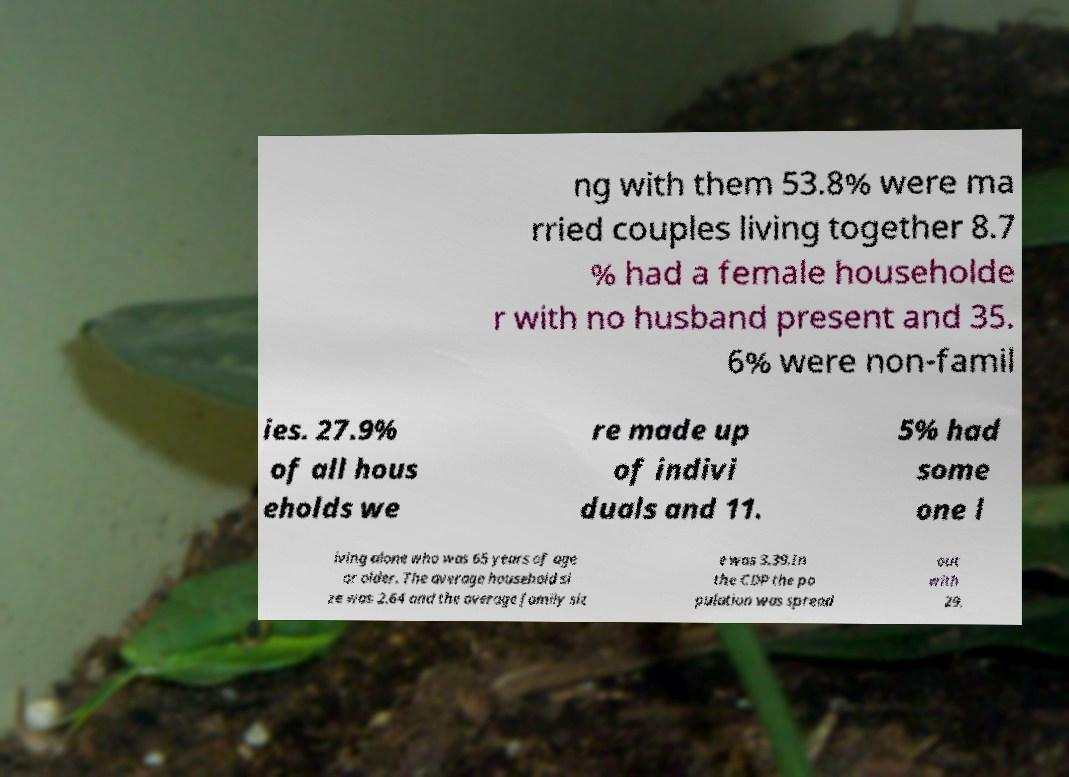Please identify and transcribe the text found in this image. ng with them 53.8% were ma rried couples living together 8.7 % had a female householde r with no husband present and 35. 6% were non-famil ies. 27.9% of all hous eholds we re made up of indivi duals and 11. 5% had some one l iving alone who was 65 years of age or older. The average household si ze was 2.64 and the average family siz e was 3.39.In the CDP the po pulation was spread out with 29. 